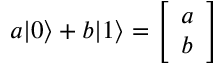Convert formula to latex. <formula><loc_0><loc_0><loc_500><loc_500>a | 0 \rangle + b | 1 \rangle = { \left [ \begin{array} { l } { a } \\ { b } \end{array} \right ] }</formula> 